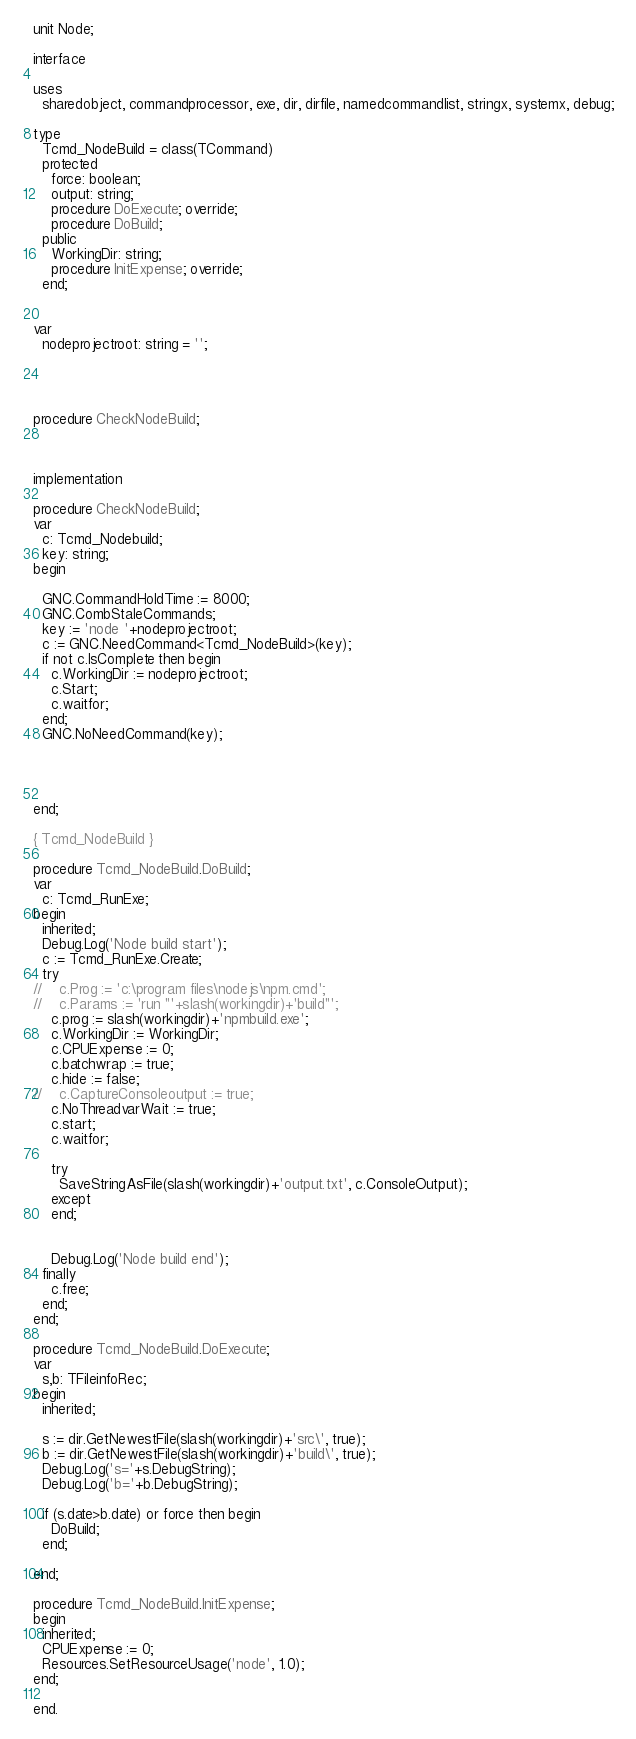Convert code to text. <code><loc_0><loc_0><loc_500><loc_500><_Pascal_>unit Node;

interface

uses
  sharedobject, commandprocessor, exe, dir, dirfile, namedcommandlist, stringx, systemx, debug;

type
  Tcmd_NodeBuild = class(TCommand)
  protected
    force: boolean;
    output: string;
    procedure DoExecute; override;
    procedure DoBuild;
  public
    WorkingDir: string;
    procedure InitExpense; override;
  end;


var
  nodeprojectroot: string = '';




procedure CheckNodeBuild;



implementation

procedure CheckNodeBuild;
var
  c: Tcmd_Nodebuild;
  key: string;
begin

  GNC.CommandHoldTime := 8000;
  GNC.CombStaleCommands;
  key := 'node '+nodeprojectroot;
  c := GNC.NeedCommand<Tcmd_NodeBuild>(key);
  if not c.IsComplete then begin
    c.WorkingDir := nodeprojectroot;
    c.Start;
    c.waitfor;
  end;
  GNC.NoNeedCommand(key);




end;

{ Tcmd_NodeBuild }

procedure Tcmd_NodeBuild.DoBuild;
var
  c: Tcmd_RunExe;
begin
  inherited;
  Debug.Log('Node build start');
  c := Tcmd_RunExe.Create;
  try
//    c.Prog := 'c:\program files\nodejs\npm.cmd';
//    c.Params := 'run "'+slash(workingdir)+'build"';
    c.prog := slash(workingdir)+'npmbuild.exe';
    c.WorkingDir := WorkingDir;
    c.CPUExpense := 0;
    c.batchwrap := true;
    c.hide := false;
//    c.CaptureConsoleoutput := true;
    c.NoThreadvarWait := true;
    c.start;
    c.waitfor;

    try
      SaveStringAsFile(slash(workingdir)+'output.txt', c.ConsoleOutput);
    except
    end;


    Debug.Log('Node build end');
  finally
    c.free;
  end;
end;

procedure Tcmd_NodeBuild.DoExecute;
var
  s,b: TFileinfoRec;
begin
  inherited;

  s := dir.GetNewestFile(slash(workingdir)+'src\', true);
  b := dir.GetNewestFile(slash(workingdir)+'build\', true);
  Debug.Log('s='+s.DebugString);
  Debug.Log('b='+b.DebugString);

  if (s.date>b.date) or force then begin
    DoBuild;
  end;

end;

procedure Tcmd_NodeBuild.InitExpense;
begin
  inherited;
  CPUExpense := 0;
  Resources.SetResourceUsage('node', 1.0);
end;

end.
</code> 